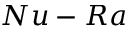<formula> <loc_0><loc_0><loc_500><loc_500>N u - R a</formula> 